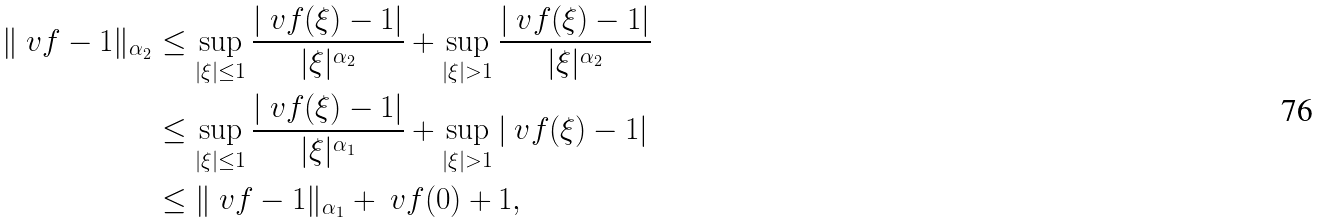<formula> <loc_0><loc_0><loc_500><loc_500>\| \ v f - 1 \| _ { \alpha _ { 2 } } & \leq \sup _ { | \xi | \leq 1 } \frac { | \ v f ( \xi ) - 1 | } { | \xi | ^ { \alpha _ { 2 } } } + \sup _ { | \xi | > 1 } \frac { | \ v f ( \xi ) - 1 | } { | \xi | ^ { \alpha _ { 2 } } } \\ & \leq \sup _ { | \xi | \leq 1 } \frac { | \ v f ( \xi ) - 1 | } { | \xi | ^ { \alpha _ { 1 } } } + \sup _ { | \xi | > 1 } | \ v f ( \xi ) - 1 | \\ & \leq \| \ v f - 1 \| _ { \alpha _ { 1 } } + \ v f ( 0 ) + 1 ,</formula> 